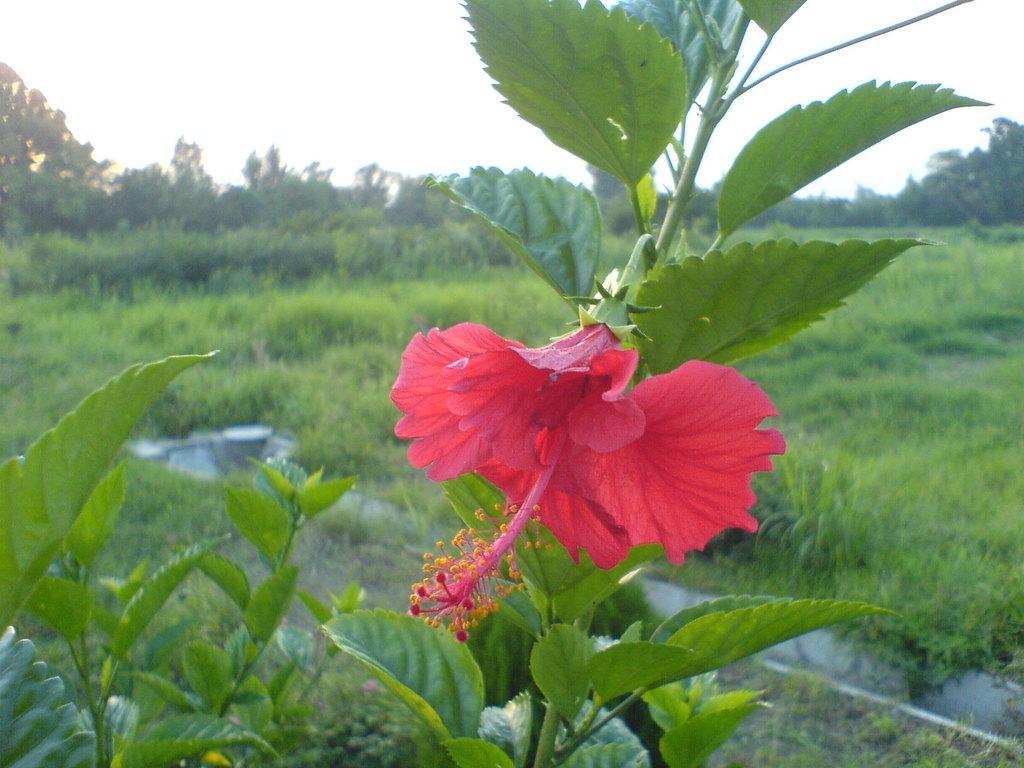How would you summarize this image in a sentence or two? This picture is mainly highlighted with a plant and this is a Datura flower. At the top of the picture we can see a sky. These are the trees. This is a green grass. This picture is full of greenery. 